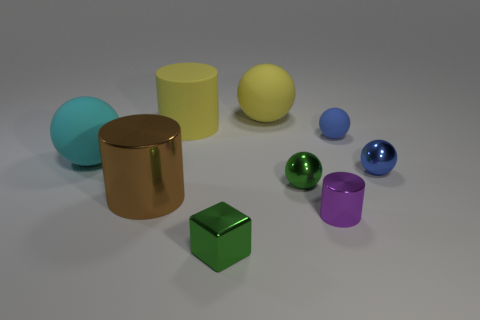The ball that is the same color as the rubber cylinder is what size? The ball that matches the color of the rubber cylinder appears to be medium-sized compared to the other objects in the image. 